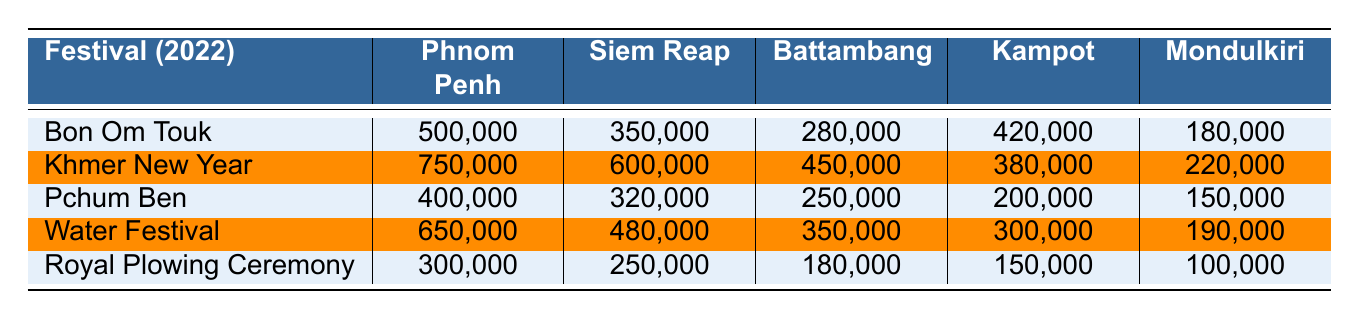What is the attendance for the Khmer New Year in Phnom Penh? According to the table, the attendance for the Khmer New Year in Phnom Penh is listed as 750,000.
Answer: 750,000 Which festival had the highest attendance in Battambang? The table indicates that the Khmer New Year had the highest attendance in Battambang, with 450,000 attendees.
Answer: Khmer New Year What is the total attendance for the Water Festival across all provinces? To find the total attendance for the Water Festival, we sum the attendance numbers across all provinces: 650,000 (Phnom Penh) + 480,000 (Siem Reap) + 350,000 (Battambang) + 300,000 (Kampot) + 190,000 (Mondulkiri) = 1,970,000.
Answer: 1,970,000 How many more people attended the Bon Om Touk festival in Kampot compared to Mondulkiri? The attendance for Bon Om Touk in Kampot is 420,000 and in Mondulkiri is 180,000. The difference is 420,000 - 180,000 = 240,000.
Answer: 240,000 What is the average attendance for the Royal Plowing Ceremony across the five provinces? To calculate the average, we add the attendance figures: 300,000 (Phnom Penh) + 250,000 (Siem Reap) + 180,000 (Battambang) + 150,000 (Kampot) + 100,000 (Mondulkiri) = 980,000. Then, we divide by the number of provinces (5): 980,000 / 5 = 196,000.
Answer: 196,000 Is the attendance for Pchum Ben higher in Siem Reap than in Kampot? The table shows that attendance for Pchum Ben in Siem Reap is 320,000 and in Kampot is 200,000. Since 320,000 is greater than 200,000, the statement is true.
Answer: Yes Which festival had the lowest total attendance across all provinces? To determine which festival had the lowest total attendance, sum the attendances for each festival: Bon Om Touk: 1,730,000, Khmer New Year: 2,100,000, Pchum Ben: 1,320,000, Water Festival: 1,970,000, Royal Plowing Ceremony: 1,020,000. The Royal Plowing Ceremony had the lowest total attendance of 1,020,000.
Answer: Royal Plowing Ceremony In which province was the attendance for Khmer New Year lower than the attendance for Water Festival? Upon reviewing the table, Phnom Penh (750,000 for Khmer New Year, 650,000 for Water Festival), Seim Reap (600,000, 480,000), and Kampot (380,000, 300,000) have higher attendance for Khmer New Year than Water Festival. Only Mondulkiri has lower attendance for Khmer New Year (220,000) than Water Festival (190,000).
Answer: Mondulkiri 